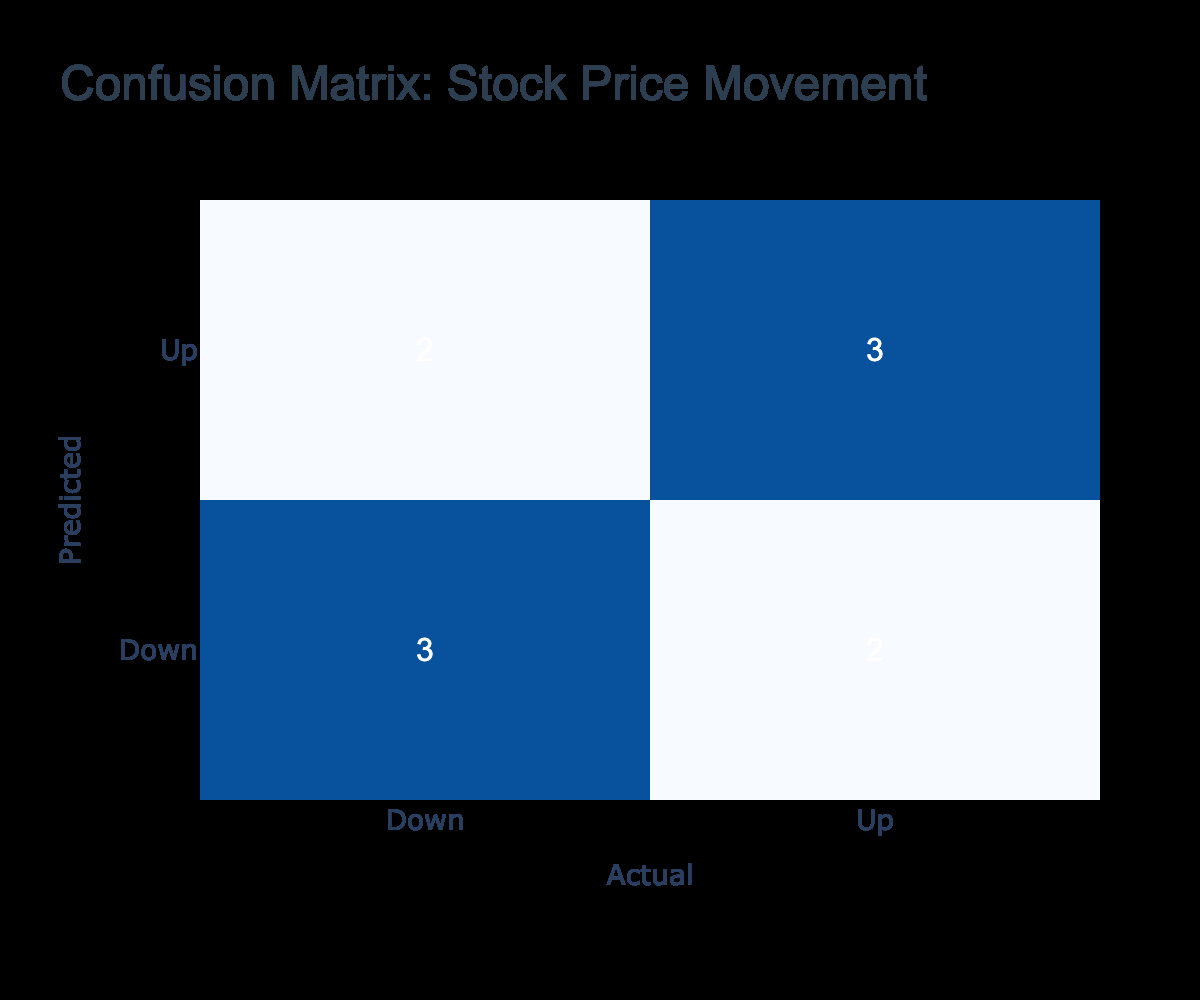What is the total number of instances where the predicted movement was "Up"? There are 5 instances in the table where the predicted movement is "Up." The companies are Apple Inc., Amazon.com Inc., Alphabet Inc., Microsoft Corporation, and Meta Platforms Inc.
Answer: 5 What percentage of the total movements predicted as "Down" resulted in an actual movement of "Down"? There are 5 predictions for "Down," and 4 of them resulted in an actual movement of "Down." To calculate the percentage, (4 / 5) * 100 = 80%.
Answer: 80% Did Adobe Inc. have a prediction that matched the actual movement? The prediction for Adobe Inc. was "Down," and the actual movement was "Up," so they did not match.
Answer: No How many companies had predicted an "Up" movement that resulted in an "Up" actual movement? There are 3 companies (Apple Inc., Alphabet Inc., and Microsoft Corporation) that predicted "Up" and had an actual movement of "Up."
Answer: 3 What is the ratio of actual movements that were "Up" to those that were "Down"? There are 5 actual movements that were "Up" (NVIDIA Corporation, Adobe Inc., and total matches from "Up" predictions) and 5 that were "Down" (Amazon.com Inc., Tesla Inc., Netflix Inc., Bernstein & Co., and total matches from "Down" predictions). The ratio is 5:5 or simplified, 1:1.
Answer: 1:1 Which company had a mismatch between its predicted and actual movement, and what was the nature of this mismatch? The companies that had mismatches were Amazon.com Inc. (predicted "Up," actual "Down"), NVIDIA Corporation (predicted "Down," actual "Up"), and Meta Platforms Inc. (predicted "Up," actual "Down"). The mismatches show both types: predicted "Up" resulting in "Down" and vice versa.
Answer: Amazon.com Inc., NVIDIA Corporation, Meta Platforms Inc What is the total count of companies that predicted "Down" but had an "Up" actual movement? There are 2 companies (NVIDIA Corporation and Adobe Inc.) where the predicted movement was "Down," but the actual movement was "Up."
Answer: 2 How many companies correctly predicted a movement, and what percentage does this represent of all predictions? There are 5 companies that correctly predicted their movements. Out of 10 total predictions, this is (5 / 10) * 100 = 50%.
Answer: 50% Was there any company where both predicted and actual movements were "Down"? Yes, there are 4 companies (Tesla Inc., Netflix Inc., Bernstein & Co., and others) where both predicted and actual movements were "Down."
Answer: Yes 